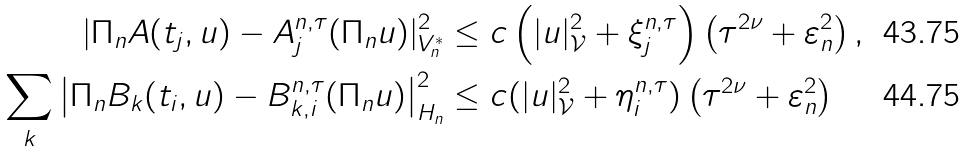<formula> <loc_0><loc_0><loc_500><loc_500>| \Pi _ { n } A ( t _ { j } , u ) - A ^ { n , \tau } _ { j } ( \Pi _ { n } u ) | _ { V _ { n } ^ { * } } ^ { 2 } & \leq c \left ( | u | _ { \mathcal { V } } ^ { 2 } + \xi _ { j } ^ { n , \tau } \right ) \left ( \tau ^ { 2 \nu } + \varepsilon _ { n } ^ { 2 } \right ) , \\ \sum _ { k } \left | \Pi _ { n } B _ { k } ( t _ { i } , u ) - B ^ { n , \tau } _ { k , i } ( \Pi _ { n } u ) \right | _ { H _ { n } } ^ { 2 } & \leq c ( | u | _ { \mathcal { V } } ^ { 2 } + \eta _ { i } ^ { n , \tau } ) \left ( \tau ^ { 2 \nu } + \varepsilon _ { n } ^ { 2 } \right )</formula> 